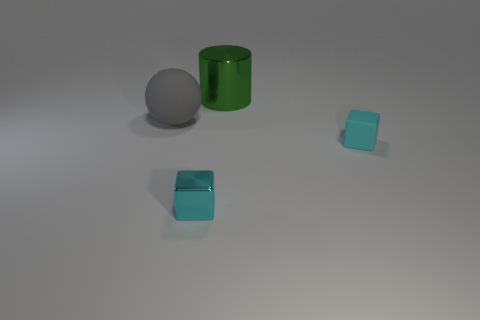Add 3 matte spheres. How many objects exist? 7 Subtract all balls. How many objects are left? 3 Subtract 0 purple blocks. How many objects are left? 4 Subtract all cyan metallic blocks. Subtract all cyan cubes. How many objects are left? 1 Add 4 large spheres. How many large spheres are left? 5 Add 1 big green cylinders. How many big green cylinders exist? 2 